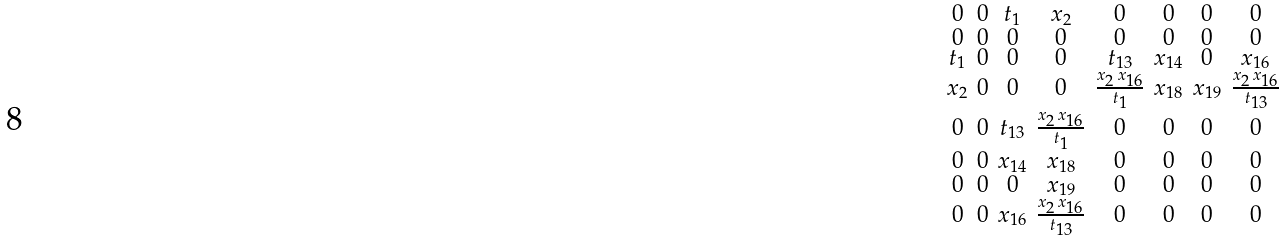Convert formula to latex. <formula><loc_0><loc_0><loc_500><loc_500>\begin{smallmatrix} 0 & 0 & { t _ { 1 } } & { x _ { 2 } } & 0 & 0 & 0 & 0 \\ 0 & 0 & 0 & 0 & 0 & 0 & 0 & 0 \\ { t _ { 1 } } & 0 & 0 & 0 & { t _ { 1 3 } } & { x _ { 1 4 } } & 0 & { x _ { 1 6 } } \\ { x _ { 2 } } & 0 & 0 & 0 & { \frac { { x _ { 2 } } \, { x _ { 1 6 } } } { { t _ { 1 } } } } & { x _ { 1 8 } } & { x _ { 1 9 } } & { \frac { { x _ { 2 } } \, { x _ { 1 6 } } } { { t _ { 1 3 } } } } \\ 0 & 0 & { t _ { 1 3 } } & { \frac { { x _ { 2 } } \, { x _ { 1 6 } } } { { t _ { 1 } } } } & 0 & 0 & 0 & 0 \\ 0 & 0 & { x _ { 1 4 } } & { x _ { 1 8 } } & 0 & 0 & 0 & 0 \\ 0 & 0 & 0 & { x _ { 1 9 } } & 0 & 0 & 0 & 0 \\ 0 & 0 & { x _ { 1 6 } } & { \frac { { x _ { 2 } } \, { x _ { 1 6 } } } { { t _ { 1 3 } } } } & 0 & 0 & 0 & 0 \end{smallmatrix}</formula> 